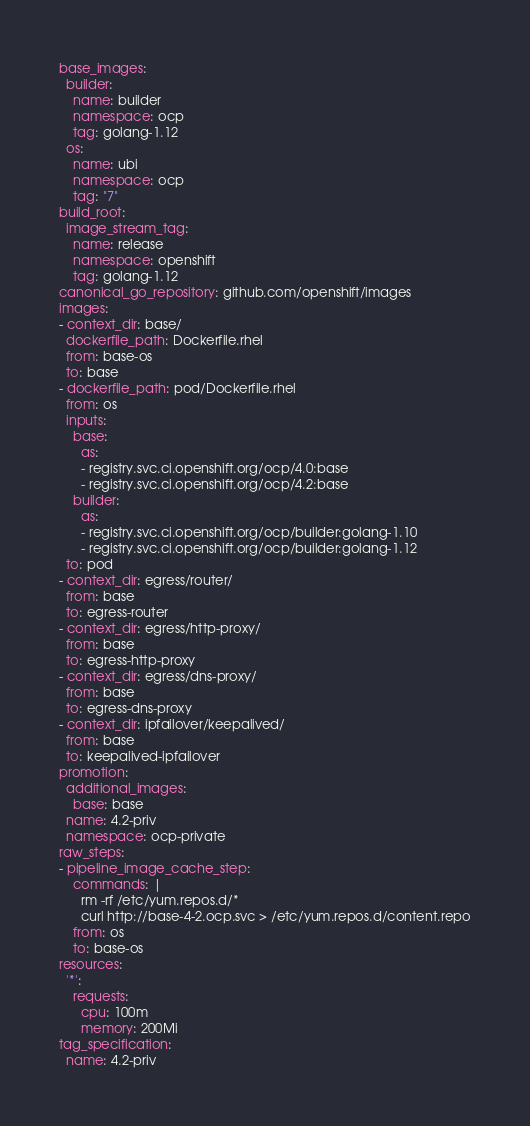<code> <loc_0><loc_0><loc_500><loc_500><_YAML_>base_images:
  builder:
    name: builder
    namespace: ocp
    tag: golang-1.12
  os:
    name: ubi
    namespace: ocp
    tag: "7"
build_root:
  image_stream_tag:
    name: release
    namespace: openshift
    tag: golang-1.12
canonical_go_repository: github.com/openshift/images
images:
- context_dir: base/
  dockerfile_path: Dockerfile.rhel
  from: base-os
  to: base
- dockerfile_path: pod/Dockerfile.rhel
  from: os
  inputs:
    base:
      as:
      - registry.svc.ci.openshift.org/ocp/4.0:base
      - registry.svc.ci.openshift.org/ocp/4.2:base
    builder:
      as:
      - registry.svc.ci.openshift.org/ocp/builder:golang-1.10
      - registry.svc.ci.openshift.org/ocp/builder:golang-1.12
  to: pod
- context_dir: egress/router/
  from: base
  to: egress-router
- context_dir: egress/http-proxy/
  from: base
  to: egress-http-proxy
- context_dir: egress/dns-proxy/
  from: base
  to: egress-dns-proxy
- context_dir: ipfailover/keepalived/
  from: base
  to: keepalived-ipfailover
promotion:
  additional_images:
    base: base
  name: 4.2-priv
  namespace: ocp-private
raw_steps:
- pipeline_image_cache_step:
    commands: |
      rm -rf /etc/yum.repos.d/*
      curl http://base-4-2.ocp.svc > /etc/yum.repos.d/content.repo
    from: os
    to: base-os
resources:
  '*':
    requests:
      cpu: 100m
      memory: 200Mi
tag_specification:
  name: 4.2-priv</code> 